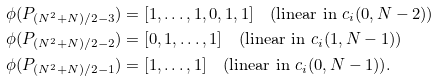Convert formula to latex. <formula><loc_0><loc_0><loc_500><loc_500>\phi ( P _ { ( N ^ { 2 } + N ) / 2 - 3 } ) & = [ 1 , \dots , 1 , 0 , 1 , 1 ] \quad ( \text {linear in } c _ { i } ( 0 , N - 2 ) ) \\ \phi ( P _ { ( N ^ { 2 } + N ) / 2 - 2 } ) & = [ 0 , 1 , \dots , 1 ] \quad ( \text {linear in } c _ { i } ( 1 , N - 1 ) ) \\ \phi ( P _ { ( N ^ { 2 } + N ) / 2 - 1 } ) & = [ 1 , \dots , 1 ] \quad ( \text {linear in } c _ { i } ( 0 , N - 1 ) ) .</formula> 